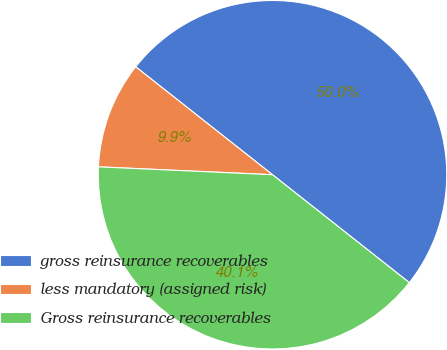Convert chart to OTSL. <chart><loc_0><loc_0><loc_500><loc_500><pie_chart><fcel>gross reinsurance recoverables<fcel>less mandatory (assigned risk)<fcel>Gross reinsurance recoverables<nl><fcel>50.0%<fcel>9.91%<fcel>40.09%<nl></chart> 